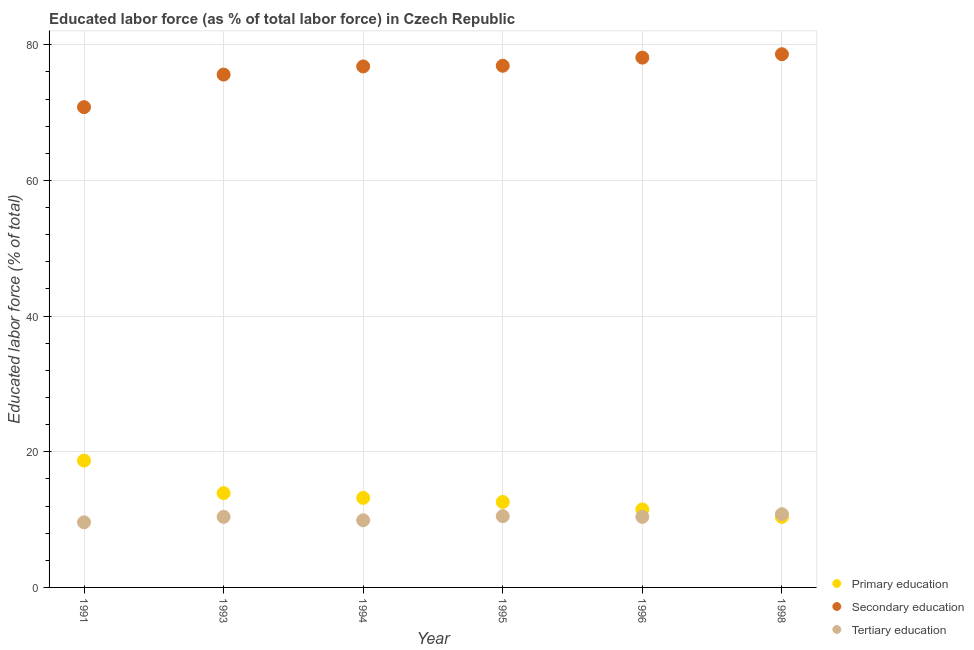How many different coloured dotlines are there?
Offer a terse response. 3. What is the percentage of labor force who received primary education in 1991?
Provide a succinct answer. 18.7. Across all years, what is the maximum percentage of labor force who received secondary education?
Ensure brevity in your answer.  78.6. Across all years, what is the minimum percentage of labor force who received secondary education?
Offer a very short reply. 70.8. In which year was the percentage of labor force who received secondary education maximum?
Make the answer very short. 1998. In which year was the percentage of labor force who received tertiary education minimum?
Offer a terse response. 1991. What is the total percentage of labor force who received tertiary education in the graph?
Your response must be concise. 61.6. What is the difference between the percentage of labor force who received tertiary education in 1994 and the percentage of labor force who received primary education in 1991?
Make the answer very short. -8.8. What is the average percentage of labor force who received secondary education per year?
Your response must be concise. 76.13. In the year 1993, what is the difference between the percentage of labor force who received secondary education and percentage of labor force who received tertiary education?
Offer a terse response. 65.2. What is the ratio of the percentage of labor force who received tertiary education in 1993 to that in 1994?
Make the answer very short. 1.05. Is the difference between the percentage of labor force who received primary education in 1995 and 1996 greater than the difference between the percentage of labor force who received secondary education in 1995 and 1996?
Make the answer very short. Yes. What is the difference between the highest and the second highest percentage of labor force who received primary education?
Ensure brevity in your answer.  4.8. What is the difference between the highest and the lowest percentage of labor force who received primary education?
Give a very brief answer. 8.3. Is it the case that in every year, the sum of the percentage of labor force who received primary education and percentage of labor force who received secondary education is greater than the percentage of labor force who received tertiary education?
Offer a terse response. Yes. Is the percentage of labor force who received primary education strictly greater than the percentage of labor force who received tertiary education over the years?
Your answer should be compact. No. Is the percentage of labor force who received tertiary education strictly less than the percentage of labor force who received primary education over the years?
Offer a very short reply. No. How many legend labels are there?
Your response must be concise. 3. What is the title of the graph?
Make the answer very short. Educated labor force (as % of total labor force) in Czech Republic. What is the label or title of the X-axis?
Offer a very short reply. Year. What is the label or title of the Y-axis?
Offer a terse response. Educated labor force (% of total). What is the Educated labor force (% of total) in Primary education in 1991?
Your response must be concise. 18.7. What is the Educated labor force (% of total) of Secondary education in 1991?
Make the answer very short. 70.8. What is the Educated labor force (% of total) of Tertiary education in 1991?
Your answer should be compact. 9.6. What is the Educated labor force (% of total) in Primary education in 1993?
Offer a very short reply. 13.9. What is the Educated labor force (% of total) in Secondary education in 1993?
Provide a short and direct response. 75.6. What is the Educated labor force (% of total) in Tertiary education in 1993?
Offer a terse response. 10.4. What is the Educated labor force (% of total) of Primary education in 1994?
Make the answer very short. 13.2. What is the Educated labor force (% of total) in Secondary education in 1994?
Offer a terse response. 76.8. What is the Educated labor force (% of total) in Tertiary education in 1994?
Provide a succinct answer. 9.9. What is the Educated labor force (% of total) of Primary education in 1995?
Your response must be concise. 12.6. What is the Educated labor force (% of total) in Secondary education in 1995?
Ensure brevity in your answer.  76.9. What is the Educated labor force (% of total) of Primary education in 1996?
Offer a terse response. 11.5. What is the Educated labor force (% of total) of Secondary education in 1996?
Make the answer very short. 78.1. What is the Educated labor force (% of total) of Tertiary education in 1996?
Make the answer very short. 10.4. What is the Educated labor force (% of total) in Primary education in 1998?
Provide a short and direct response. 10.4. What is the Educated labor force (% of total) of Secondary education in 1998?
Provide a short and direct response. 78.6. What is the Educated labor force (% of total) of Tertiary education in 1998?
Offer a terse response. 10.8. Across all years, what is the maximum Educated labor force (% of total) in Primary education?
Ensure brevity in your answer.  18.7. Across all years, what is the maximum Educated labor force (% of total) in Secondary education?
Your answer should be very brief. 78.6. Across all years, what is the maximum Educated labor force (% of total) in Tertiary education?
Give a very brief answer. 10.8. Across all years, what is the minimum Educated labor force (% of total) of Primary education?
Offer a very short reply. 10.4. Across all years, what is the minimum Educated labor force (% of total) in Secondary education?
Give a very brief answer. 70.8. Across all years, what is the minimum Educated labor force (% of total) of Tertiary education?
Your answer should be compact. 9.6. What is the total Educated labor force (% of total) of Primary education in the graph?
Provide a short and direct response. 80.3. What is the total Educated labor force (% of total) in Secondary education in the graph?
Provide a succinct answer. 456.8. What is the total Educated labor force (% of total) of Tertiary education in the graph?
Ensure brevity in your answer.  61.6. What is the difference between the Educated labor force (% of total) of Tertiary education in 1991 and that in 1993?
Your answer should be compact. -0.8. What is the difference between the Educated labor force (% of total) of Primary education in 1991 and that in 1994?
Provide a succinct answer. 5.5. What is the difference between the Educated labor force (% of total) of Tertiary education in 1991 and that in 1994?
Offer a very short reply. -0.3. What is the difference between the Educated labor force (% of total) in Primary education in 1991 and that in 1995?
Make the answer very short. 6.1. What is the difference between the Educated labor force (% of total) of Secondary education in 1991 and that in 1995?
Offer a terse response. -6.1. What is the difference between the Educated labor force (% of total) in Primary education in 1991 and that in 1996?
Provide a short and direct response. 7.2. What is the difference between the Educated labor force (% of total) in Secondary education in 1991 and that in 1996?
Your answer should be very brief. -7.3. What is the difference between the Educated labor force (% of total) in Tertiary education in 1991 and that in 1996?
Your response must be concise. -0.8. What is the difference between the Educated labor force (% of total) of Tertiary education in 1993 and that in 1994?
Your response must be concise. 0.5. What is the difference between the Educated labor force (% of total) of Primary education in 1993 and that in 1996?
Make the answer very short. 2.4. What is the difference between the Educated labor force (% of total) of Primary education in 1993 and that in 1998?
Make the answer very short. 3.5. What is the difference between the Educated labor force (% of total) of Secondary education in 1993 and that in 1998?
Keep it short and to the point. -3. What is the difference between the Educated labor force (% of total) of Secondary education in 1994 and that in 1996?
Give a very brief answer. -1.3. What is the difference between the Educated labor force (% of total) in Tertiary education in 1994 and that in 1996?
Offer a terse response. -0.5. What is the difference between the Educated labor force (% of total) in Tertiary education in 1994 and that in 1998?
Keep it short and to the point. -0.9. What is the difference between the Educated labor force (% of total) of Primary education in 1995 and that in 1996?
Give a very brief answer. 1.1. What is the difference between the Educated labor force (% of total) in Secondary education in 1995 and that in 1996?
Offer a very short reply. -1.2. What is the difference between the Educated labor force (% of total) in Secondary education in 1995 and that in 1998?
Give a very brief answer. -1.7. What is the difference between the Educated labor force (% of total) in Primary education in 1991 and the Educated labor force (% of total) in Secondary education in 1993?
Your answer should be very brief. -56.9. What is the difference between the Educated labor force (% of total) in Primary education in 1991 and the Educated labor force (% of total) in Tertiary education in 1993?
Provide a short and direct response. 8.3. What is the difference between the Educated labor force (% of total) of Secondary education in 1991 and the Educated labor force (% of total) of Tertiary education in 1993?
Make the answer very short. 60.4. What is the difference between the Educated labor force (% of total) in Primary education in 1991 and the Educated labor force (% of total) in Secondary education in 1994?
Your answer should be compact. -58.1. What is the difference between the Educated labor force (% of total) in Secondary education in 1991 and the Educated labor force (% of total) in Tertiary education in 1994?
Ensure brevity in your answer.  60.9. What is the difference between the Educated labor force (% of total) in Primary education in 1991 and the Educated labor force (% of total) in Secondary education in 1995?
Your answer should be compact. -58.2. What is the difference between the Educated labor force (% of total) in Secondary education in 1991 and the Educated labor force (% of total) in Tertiary education in 1995?
Ensure brevity in your answer.  60.3. What is the difference between the Educated labor force (% of total) of Primary education in 1991 and the Educated labor force (% of total) of Secondary education in 1996?
Your response must be concise. -59.4. What is the difference between the Educated labor force (% of total) in Secondary education in 1991 and the Educated labor force (% of total) in Tertiary education in 1996?
Provide a short and direct response. 60.4. What is the difference between the Educated labor force (% of total) in Primary education in 1991 and the Educated labor force (% of total) in Secondary education in 1998?
Keep it short and to the point. -59.9. What is the difference between the Educated labor force (% of total) in Primary education in 1991 and the Educated labor force (% of total) in Tertiary education in 1998?
Your response must be concise. 7.9. What is the difference between the Educated labor force (% of total) in Secondary education in 1991 and the Educated labor force (% of total) in Tertiary education in 1998?
Your answer should be very brief. 60. What is the difference between the Educated labor force (% of total) in Primary education in 1993 and the Educated labor force (% of total) in Secondary education in 1994?
Your answer should be compact. -62.9. What is the difference between the Educated labor force (% of total) in Primary education in 1993 and the Educated labor force (% of total) in Tertiary education in 1994?
Make the answer very short. 4. What is the difference between the Educated labor force (% of total) in Secondary education in 1993 and the Educated labor force (% of total) in Tertiary education in 1994?
Keep it short and to the point. 65.7. What is the difference between the Educated labor force (% of total) in Primary education in 1993 and the Educated labor force (% of total) in Secondary education in 1995?
Keep it short and to the point. -63. What is the difference between the Educated labor force (% of total) in Primary education in 1993 and the Educated labor force (% of total) in Tertiary education in 1995?
Provide a succinct answer. 3.4. What is the difference between the Educated labor force (% of total) in Secondary education in 1993 and the Educated labor force (% of total) in Tertiary education in 1995?
Offer a very short reply. 65.1. What is the difference between the Educated labor force (% of total) of Primary education in 1993 and the Educated labor force (% of total) of Secondary education in 1996?
Your response must be concise. -64.2. What is the difference between the Educated labor force (% of total) in Primary education in 1993 and the Educated labor force (% of total) in Tertiary education in 1996?
Your answer should be compact. 3.5. What is the difference between the Educated labor force (% of total) of Secondary education in 1993 and the Educated labor force (% of total) of Tertiary education in 1996?
Your answer should be very brief. 65.2. What is the difference between the Educated labor force (% of total) in Primary education in 1993 and the Educated labor force (% of total) in Secondary education in 1998?
Give a very brief answer. -64.7. What is the difference between the Educated labor force (% of total) in Secondary education in 1993 and the Educated labor force (% of total) in Tertiary education in 1998?
Your response must be concise. 64.8. What is the difference between the Educated labor force (% of total) of Primary education in 1994 and the Educated labor force (% of total) of Secondary education in 1995?
Offer a terse response. -63.7. What is the difference between the Educated labor force (% of total) in Primary education in 1994 and the Educated labor force (% of total) in Tertiary education in 1995?
Provide a short and direct response. 2.7. What is the difference between the Educated labor force (% of total) in Secondary education in 1994 and the Educated labor force (% of total) in Tertiary education in 1995?
Provide a short and direct response. 66.3. What is the difference between the Educated labor force (% of total) of Primary education in 1994 and the Educated labor force (% of total) of Secondary education in 1996?
Offer a very short reply. -64.9. What is the difference between the Educated labor force (% of total) in Primary education in 1994 and the Educated labor force (% of total) in Tertiary education in 1996?
Provide a short and direct response. 2.8. What is the difference between the Educated labor force (% of total) in Secondary education in 1994 and the Educated labor force (% of total) in Tertiary education in 1996?
Provide a short and direct response. 66.4. What is the difference between the Educated labor force (% of total) in Primary education in 1994 and the Educated labor force (% of total) in Secondary education in 1998?
Provide a succinct answer. -65.4. What is the difference between the Educated labor force (% of total) in Primary education in 1995 and the Educated labor force (% of total) in Secondary education in 1996?
Provide a short and direct response. -65.5. What is the difference between the Educated labor force (% of total) of Primary education in 1995 and the Educated labor force (% of total) of Tertiary education in 1996?
Ensure brevity in your answer.  2.2. What is the difference between the Educated labor force (% of total) in Secondary education in 1995 and the Educated labor force (% of total) in Tertiary education in 1996?
Keep it short and to the point. 66.5. What is the difference between the Educated labor force (% of total) in Primary education in 1995 and the Educated labor force (% of total) in Secondary education in 1998?
Your response must be concise. -66. What is the difference between the Educated labor force (% of total) of Secondary education in 1995 and the Educated labor force (% of total) of Tertiary education in 1998?
Your response must be concise. 66.1. What is the difference between the Educated labor force (% of total) of Primary education in 1996 and the Educated labor force (% of total) of Secondary education in 1998?
Offer a very short reply. -67.1. What is the difference between the Educated labor force (% of total) in Primary education in 1996 and the Educated labor force (% of total) in Tertiary education in 1998?
Offer a very short reply. 0.7. What is the difference between the Educated labor force (% of total) of Secondary education in 1996 and the Educated labor force (% of total) of Tertiary education in 1998?
Offer a very short reply. 67.3. What is the average Educated labor force (% of total) in Primary education per year?
Offer a terse response. 13.38. What is the average Educated labor force (% of total) in Secondary education per year?
Your answer should be compact. 76.13. What is the average Educated labor force (% of total) of Tertiary education per year?
Your answer should be very brief. 10.27. In the year 1991, what is the difference between the Educated labor force (% of total) of Primary education and Educated labor force (% of total) of Secondary education?
Provide a succinct answer. -52.1. In the year 1991, what is the difference between the Educated labor force (% of total) in Secondary education and Educated labor force (% of total) in Tertiary education?
Your answer should be very brief. 61.2. In the year 1993, what is the difference between the Educated labor force (% of total) of Primary education and Educated labor force (% of total) of Secondary education?
Offer a terse response. -61.7. In the year 1993, what is the difference between the Educated labor force (% of total) in Primary education and Educated labor force (% of total) in Tertiary education?
Keep it short and to the point. 3.5. In the year 1993, what is the difference between the Educated labor force (% of total) of Secondary education and Educated labor force (% of total) of Tertiary education?
Your answer should be compact. 65.2. In the year 1994, what is the difference between the Educated labor force (% of total) in Primary education and Educated labor force (% of total) in Secondary education?
Make the answer very short. -63.6. In the year 1994, what is the difference between the Educated labor force (% of total) of Secondary education and Educated labor force (% of total) of Tertiary education?
Give a very brief answer. 66.9. In the year 1995, what is the difference between the Educated labor force (% of total) in Primary education and Educated labor force (% of total) in Secondary education?
Your answer should be compact. -64.3. In the year 1995, what is the difference between the Educated labor force (% of total) of Secondary education and Educated labor force (% of total) of Tertiary education?
Offer a very short reply. 66.4. In the year 1996, what is the difference between the Educated labor force (% of total) of Primary education and Educated labor force (% of total) of Secondary education?
Make the answer very short. -66.6. In the year 1996, what is the difference between the Educated labor force (% of total) of Primary education and Educated labor force (% of total) of Tertiary education?
Offer a terse response. 1.1. In the year 1996, what is the difference between the Educated labor force (% of total) of Secondary education and Educated labor force (% of total) of Tertiary education?
Your response must be concise. 67.7. In the year 1998, what is the difference between the Educated labor force (% of total) in Primary education and Educated labor force (% of total) in Secondary education?
Your answer should be very brief. -68.2. In the year 1998, what is the difference between the Educated labor force (% of total) of Primary education and Educated labor force (% of total) of Tertiary education?
Ensure brevity in your answer.  -0.4. In the year 1998, what is the difference between the Educated labor force (% of total) of Secondary education and Educated labor force (% of total) of Tertiary education?
Offer a terse response. 67.8. What is the ratio of the Educated labor force (% of total) in Primary education in 1991 to that in 1993?
Offer a terse response. 1.35. What is the ratio of the Educated labor force (% of total) in Secondary education in 1991 to that in 1993?
Your response must be concise. 0.94. What is the ratio of the Educated labor force (% of total) in Primary education in 1991 to that in 1994?
Your response must be concise. 1.42. What is the ratio of the Educated labor force (% of total) in Secondary education in 1991 to that in 1994?
Your answer should be compact. 0.92. What is the ratio of the Educated labor force (% of total) of Tertiary education in 1991 to that in 1994?
Offer a very short reply. 0.97. What is the ratio of the Educated labor force (% of total) in Primary education in 1991 to that in 1995?
Give a very brief answer. 1.48. What is the ratio of the Educated labor force (% of total) of Secondary education in 1991 to that in 1995?
Offer a very short reply. 0.92. What is the ratio of the Educated labor force (% of total) of Tertiary education in 1991 to that in 1995?
Your answer should be very brief. 0.91. What is the ratio of the Educated labor force (% of total) of Primary education in 1991 to that in 1996?
Provide a succinct answer. 1.63. What is the ratio of the Educated labor force (% of total) of Secondary education in 1991 to that in 1996?
Provide a short and direct response. 0.91. What is the ratio of the Educated labor force (% of total) of Tertiary education in 1991 to that in 1996?
Your response must be concise. 0.92. What is the ratio of the Educated labor force (% of total) in Primary education in 1991 to that in 1998?
Offer a terse response. 1.8. What is the ratio of the Educated labor force (% of total) of Secondary education in 1991 to that in 1998?
Ensure brevity in your answer.  0.9. What is the ratio of the Educated labor force (% of total) in Primary education in 1993 to that in 1994?
Keep it short and to the point. 1.05. What is the ratio of the Educated labor force (% of total) in Secondary education in 1993 to that in 1994?
Provide a short and direct response. 0.98. What is the ratio of the Educated labor force (% of total) of Tertiary education in 1993 to that in 1994?
Keep it short and to the point. 1.05. What is the ratio of the Educated labor force (% of total) of Primary education in 1993 to that in 1995?
Your answer should be compact. 1.1. What is the ratio of the Educated labor force (% of total) of Secondary education in 1993 to that in 1995?
Make the answer very short. 0.98. What is the ratio of the Educated labor force (% of total) of Primary education in 1993 to that in 1996?
Offer a terse response. 1.21. What is the ratio of the Educated labor force (% of total) in Tertiary education in 1993 to that in 1996?
Make the answer very short. 1. What is the ratio of the Educated labor force (% of total) of Primary education in 1993 to that in 1998?
Provide a succinct answer. 1.34. What is the ratio of the Educated labor force (% of total) in Secondary education in 1993 to that in 1998?
Your answer should be compact. 0.96. What is the ratio of the Educated labor force (% of total) in Tertiary education in 1993 to that in 1998?
Your response must be concise. 0.96. What is the ratio of the Educated labor force (% of total) of Primary education in 1994 to that in 1995?
Your answer should be very brief. 1.05. What is the ratio of the Educated labor force (% of total) of Secondary education in 1994 to that in 1995?
Your answer should be very brief. 1. What is the ratio of the Educated labor force (% of total) of Tertiary education in 1994 to that in 1995?
Give a very brief answer. 0.94. What is the ratio of the Educated labor force (% of total) in Primary education in 1994 to that in 1996?
Provide a short and direct response. 1.15. What is the ratio of the Educated labor force (% of total) of Secondary education in 1994 to that in 1996?
Your answer should be compact. 0.98. What is the ratio of the Educated labor force (% of total) in Tertiary education in 1994 to that in 1996?
Your answer should be very brief. 0.95. What is the ratio of the Educated labor force (% of total) in Primary education in 1994 to that in 1998?
Give a very brief answer. 1.27. What is the ratio of the Educated labor force (% of total) of Secondary education in 1994 to that in 1998?
Provide a short and direct response. 0.98. What is the ratio of the Educated labor force (% of total) of Tertiary education in 1994 to that in 1998?
Your response must be concise. 0.92. What is the ratio of the Educated labor force (% of total) in Primary education in 1995 to that in 1996?
Make the answer very short. 1.1. What is the ratio of the Educated labor force (% of total) in Secondary education in 1995 to that in 1996?
Keep it short and to the point. 0.98. What is the ratio of the Educated labor force (% of total) of Tertiary education in 1995 to that in 1996?
Make the answer very short. 1.01. What is the ratio of the Educated labor force (% of total) in Primary education in 1995 to that in 1998?
Give a very brief answer. 1.21. What is the ratio of the Educated labor force (% of total) of Secondary education in 1995 to that in 1998?
Your response must be concise. 0.98. What is the ratio of the Educated labor force (% of total) in Tertiary education in 1995 to that in 1998?
Provide a succinct answer. 0.97. What is the ratio of the Educated labor force (% of total) of Primary education in 1996 to that in 1998?
Make the answer very short. 1.11. What is the ratio of the Educated labor force (% of total) of Secondary education in 1996 to that in 1998?
Give a very brief answer. 0.99. What is the difference between the highest and the second highest Educated labor force (% of total) in Primary education?
Make the answer very short. 4.8. What is the difference between the highest and the lowest Educated labor force (% of total) in Primary education?
Your response must be concise. 8.3. 